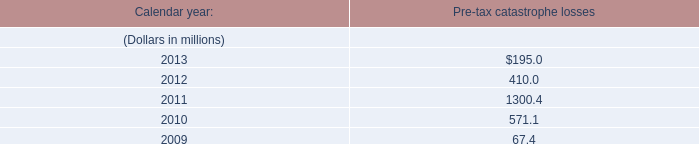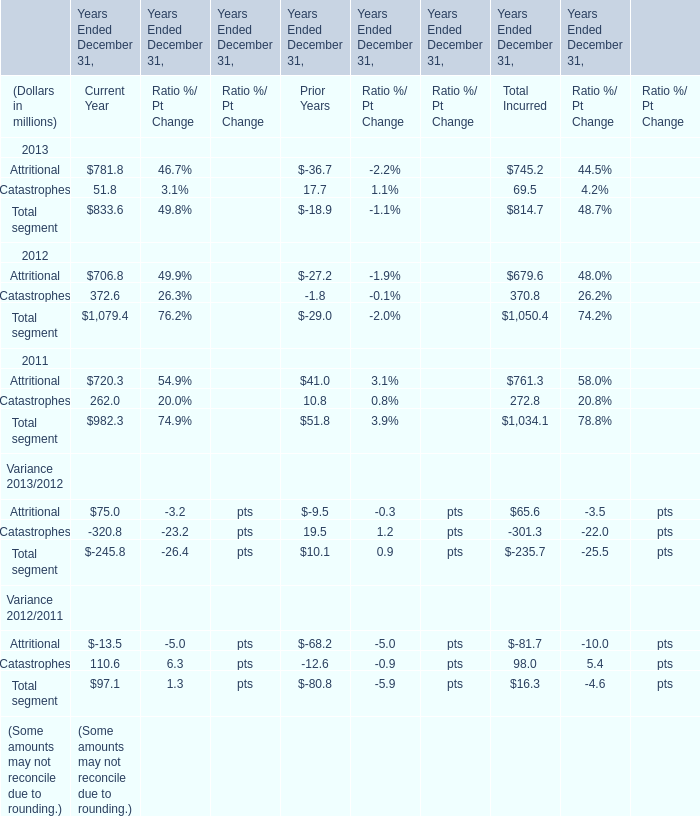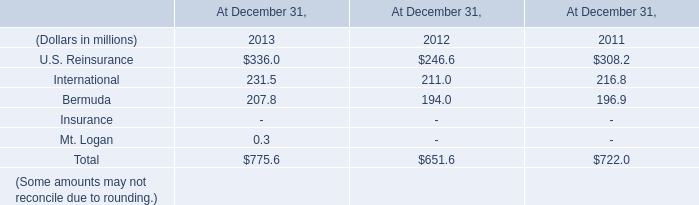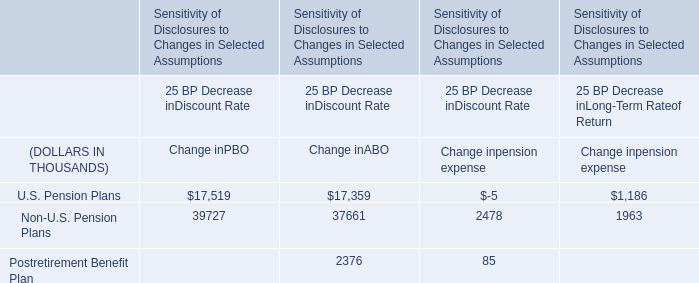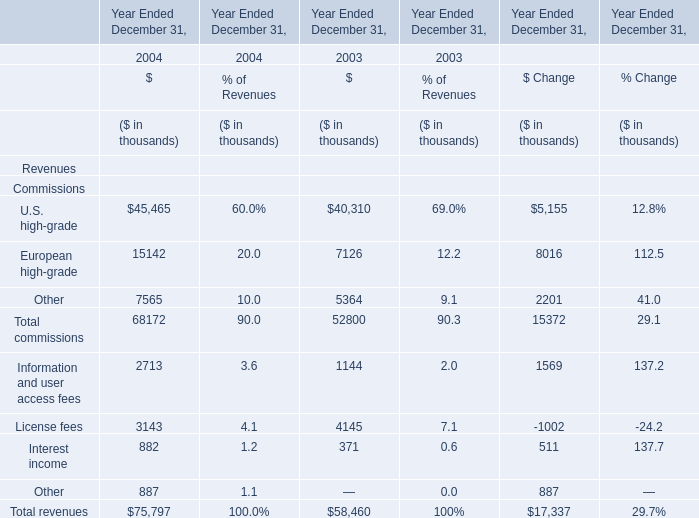What is the ratio of Catastrophes of Current Year in Table 1 to the U.S. Reinsurance in Table 2 in 2012? 
Computations: (372.6 / 246.6)
Answer: 1.51095. 